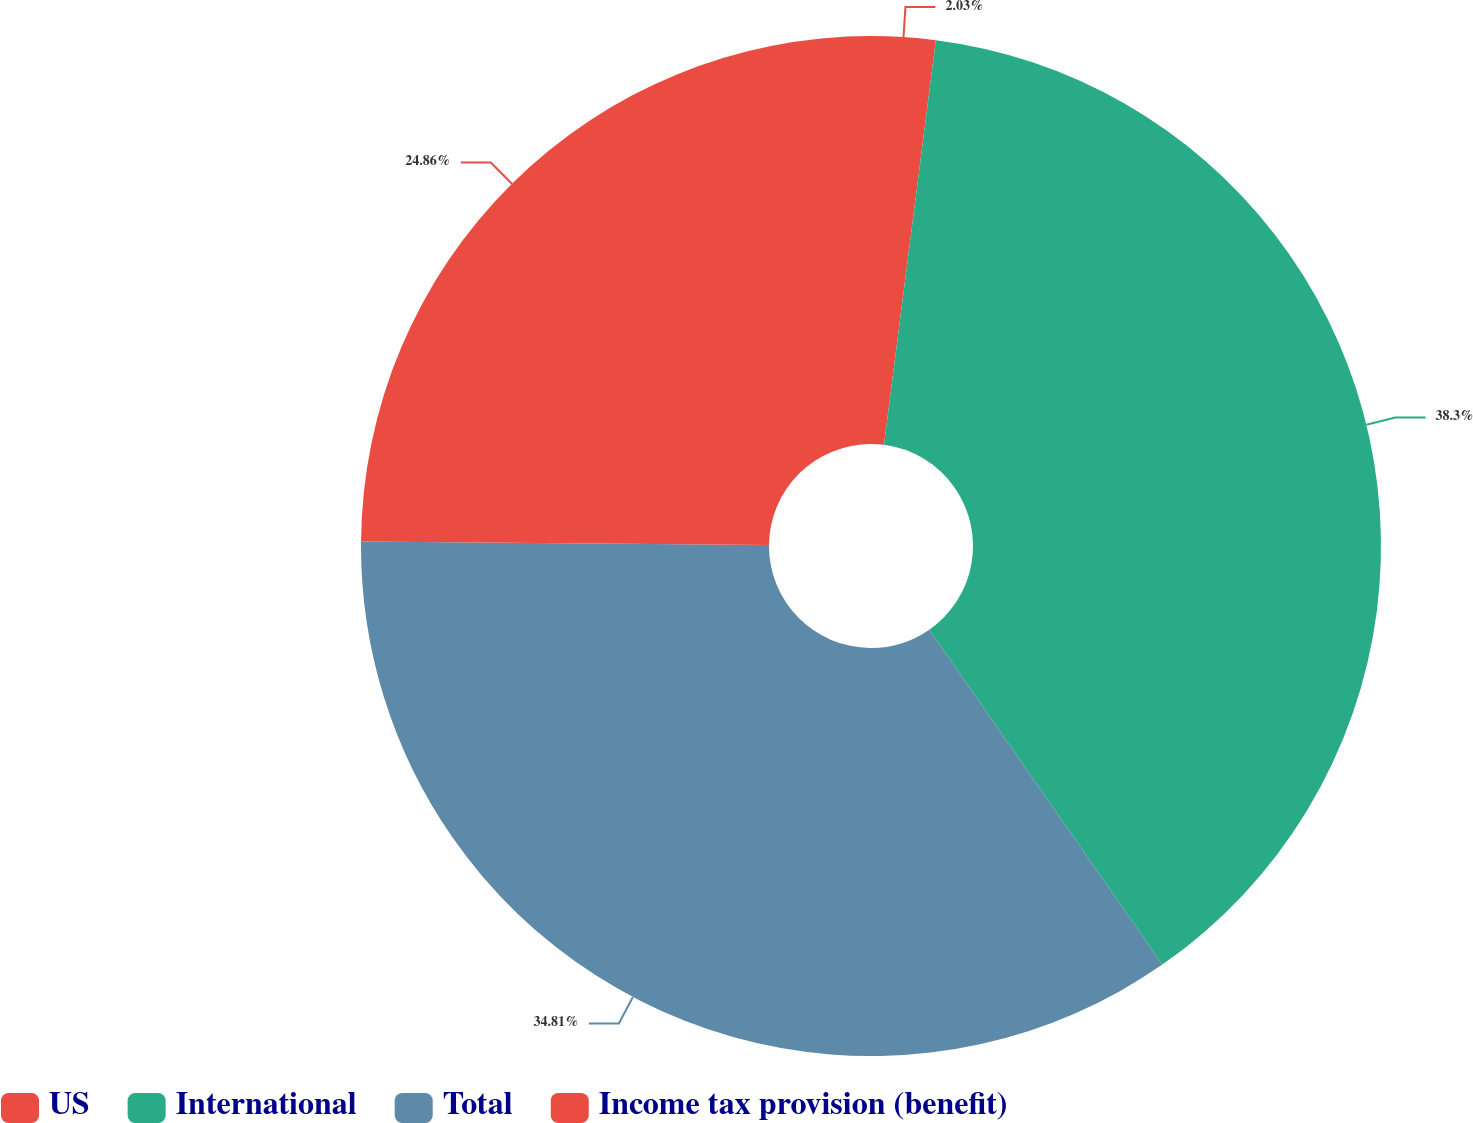<chart> <loc_0><loc_0><loc_500><loc_500><pie_chart><fcel>US<fcel>International<fcel>Total<fcel>Income tax provision (benefit)<nl><fcel>2.03%<fcel>38.29%<fcel>34.81%<fcel>24.86%<nl></chart> 